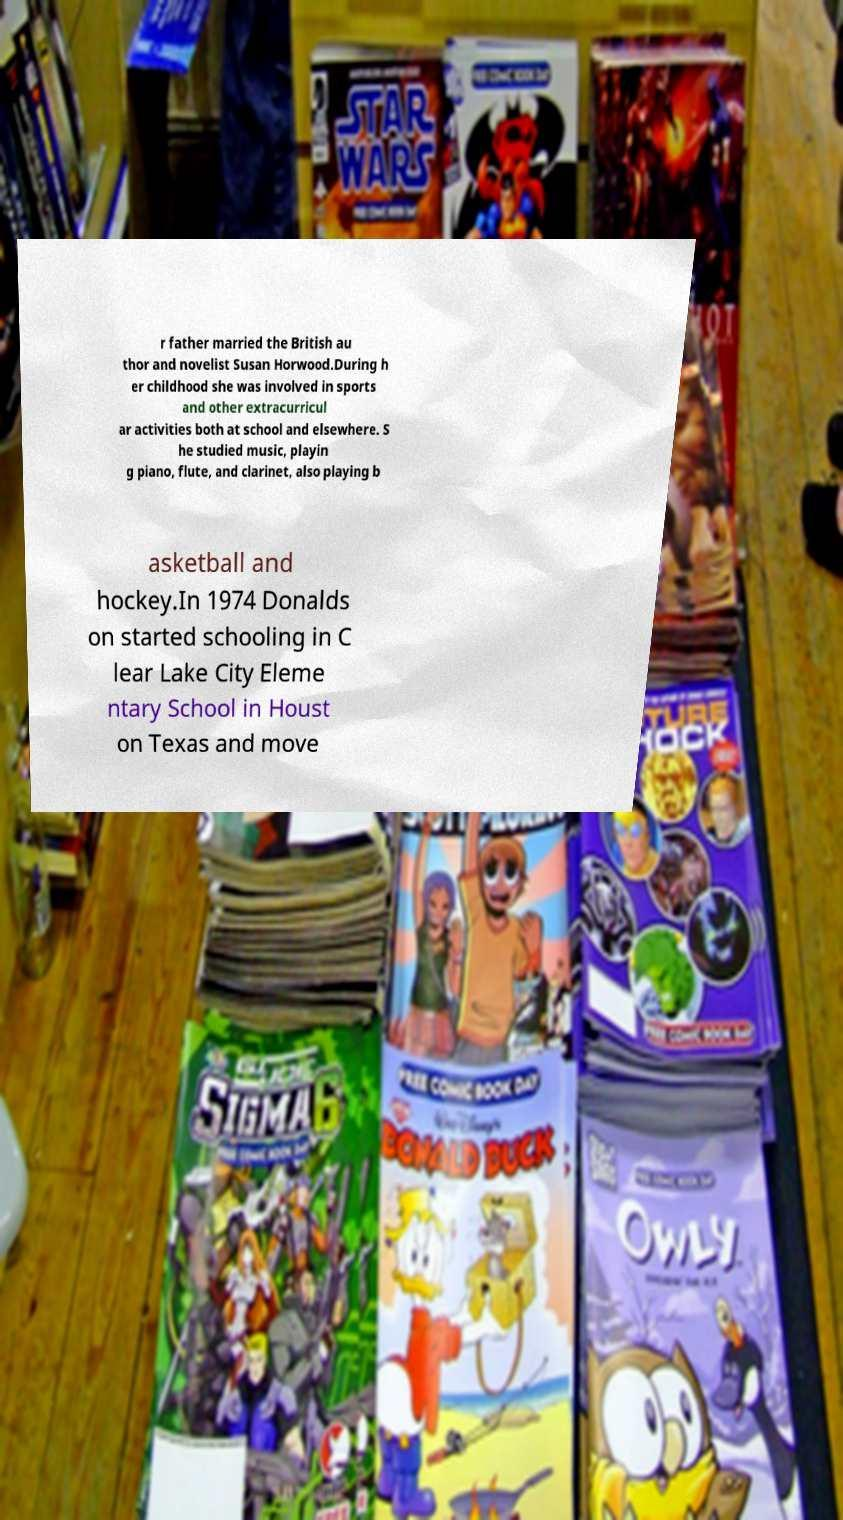For documentation purposes, I need the text within this image transcribed. Could you provide that? r father married the British au thor and novelist Susan Horwood.During h er childhood she was involved in sports and other extracurricul ar activities both at school and elsewhere. S he studied music, playin g piano, flute, and clarinet, also playing b asketball and hockey.In 1974 Donalds on started schooling in C lear Lake City Eleme ntary School in Houst on Texas and move 